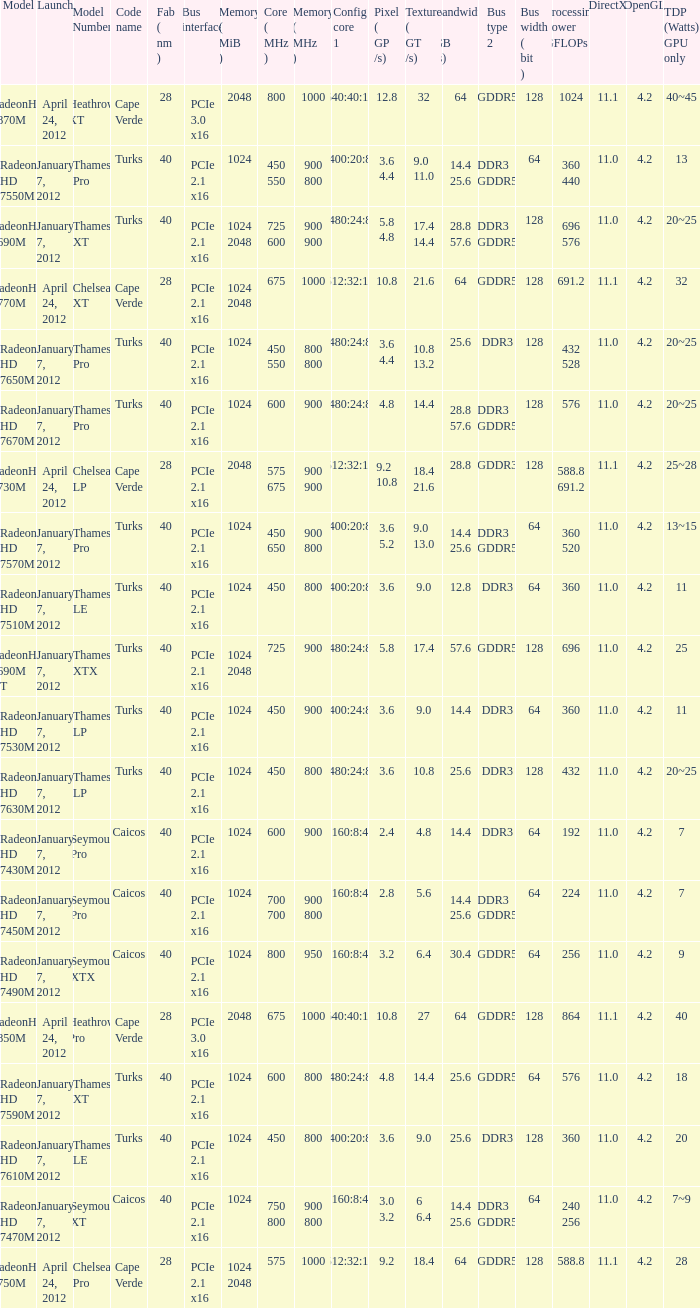What is the config core 1 of the model with a processing power GFLOPs of 432? 480:24:8. 